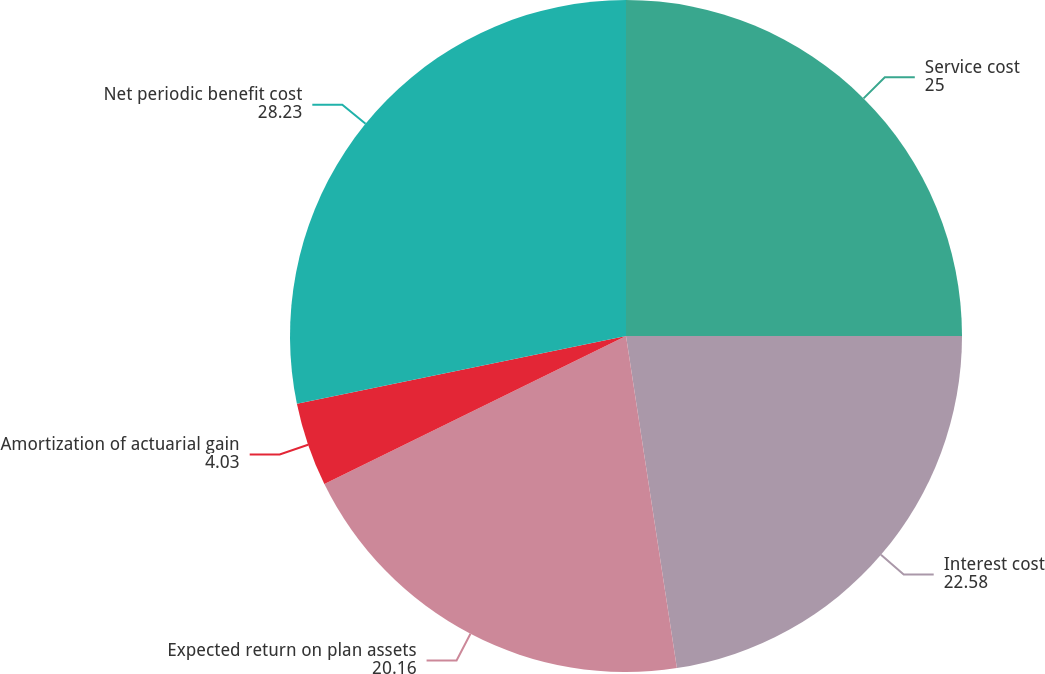Convert chart. <chart><loc_0><loc_0><loc_500><loc_500><pie_chart><fcel>Service cost<fcel>Interest cost<fcel>Expected return on plan assets<fcel>Amortization of actuarial gain<fcel>Net periodic benefit cost<nl><fcel>25.0%<fcel>22.58%<fcel>20.16%<fcel>4.03%<fcel>28.23%<nl></chart> 